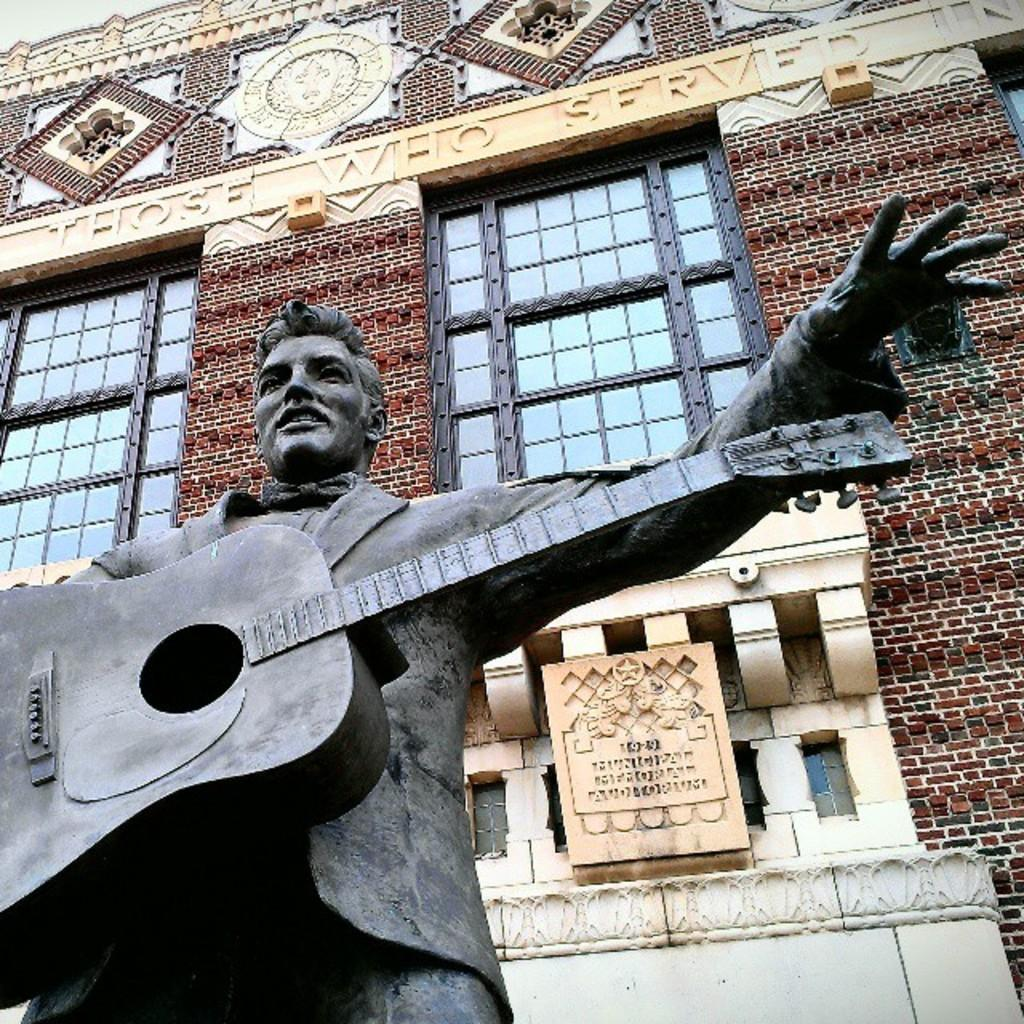What is the main subject of the image? There is a statue of a man in the image. What is the man holding in his hands? The man is holding a guitar in his hands. What can be seen in the background of the image? There is a building in the background of the image. Can you describe the building in the image? The building has windows and beautiful architecture. What type of reaction can be seen from the statue when it hears the sorting of offers? There is no reaction from the statue, as it is a statue and cannot hear or respond to any offers. 